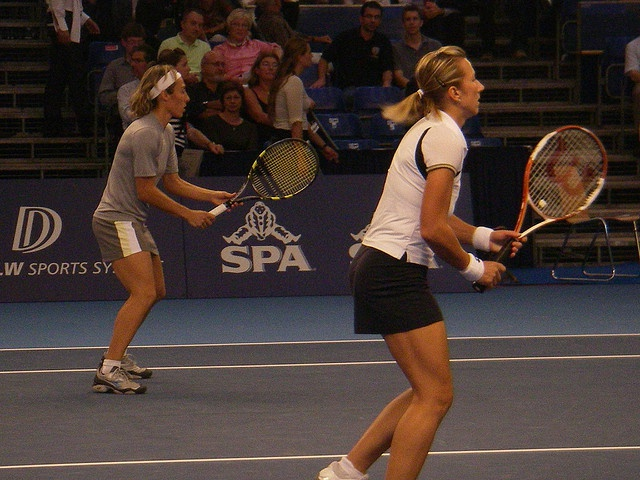Describe the objects in this image and their specific colors. I can see people in black, brown, maroon, and tan tones, people in black, maroon, and gray tones, people in black, maroon, and gray tones, tennis racket in black, maroon, and brown tones, and chair in black, maroon, and brown tones in this image. 